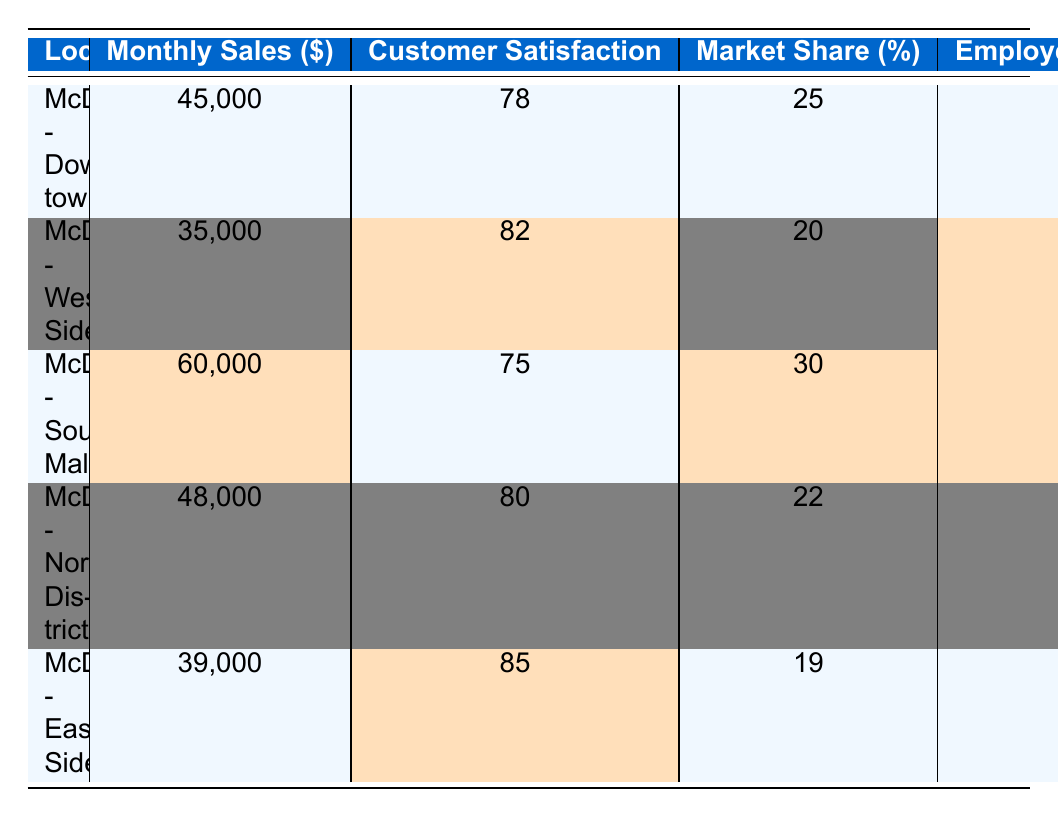What is the location with the highest monthly sales? The table shows that McDonald's - South Mall has the highest monthly sales at 60,000.
Answer: McDonald's - South Mall What is the customer satisfaction score for McDonald's - East Side? According to the table, McDonald's - East Side has a customer satisfaction score of 85.
Answer: 85 What is the market share percentage for McDonald's - Downtown? The market share for McDonald's - Downtown is listed as 25%.
Answer: 25% Is McDonald's - West Side's employee turnover rate higher than that of McDonald's - North District? The table indicates that McDonald's - West Side has a turnover rate of 20%, while North District has 18%, so West Side's rate is indeed higher.
Answer: Yes What are the average monthly sales for all five locations? The monthly sales are 45,000 + 35,000 + 60,000 + 48,000 + 39,000 = 227,000. Dividing this by the 5 locations gives an average of 227,000 / 5 = 45,400.
Answer: 45,400 Which location has the lowest health inspection score? By reviewing the health inspection scores, I see that McDonald's - West Side has the lowest score at 88.
Answer: McDonald's - West Side Is customer satisfaction consistent across all locations? No, the scores vary; for instance, Downtown has 78, while East Side has 85, indicating inconsistency in customer satisfaction.
Answer: No What is the total employee turnover percentage for all locations combined? The employee turnover rates are 15 + 20 + 10 + 18 + 17 = 80. Since there are 5 locations, the average turnover percentage is 80 / 5 = 16%.
Answer: 16% Are there any locations with a health inspection score above 90? Yes, both McDonald's - Downtown and McDonald's - North District have health inspection scores above 90.
Answer: Yes Which location has a higher market share: McDonald's - South Mall or McDonald's - Downtown? South Mall has a market share of 30% compared to Downtown's 25%, indicating South Mall has a higher market share.
Answer: McDonald's - South Mall 